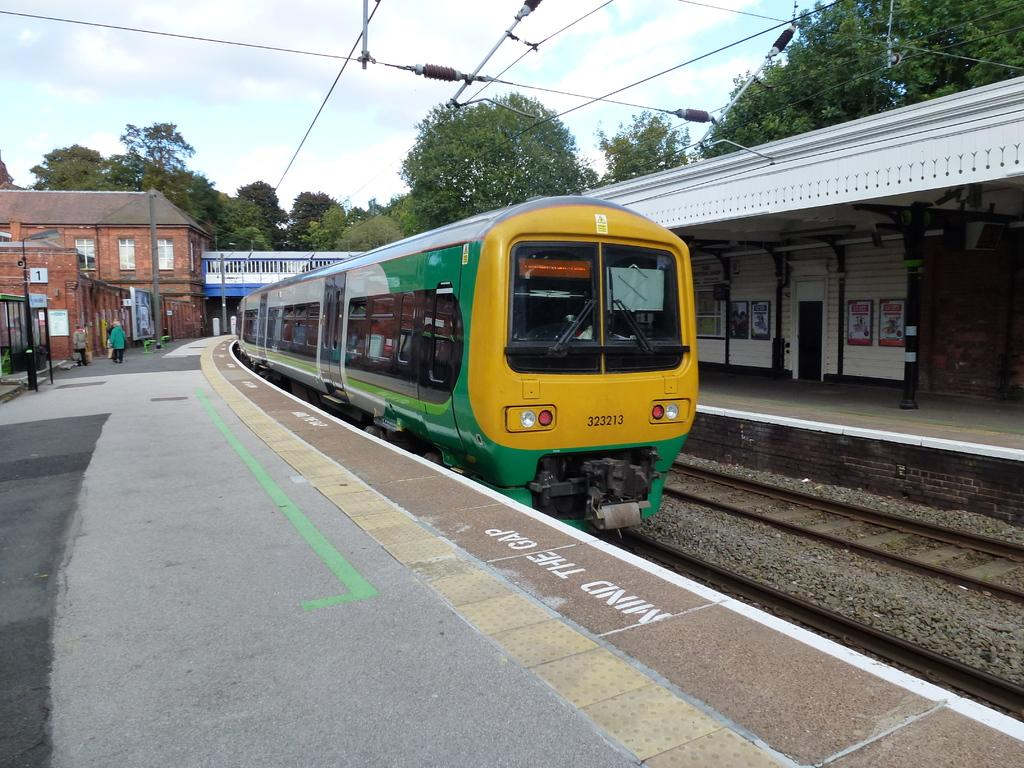<image>
Offer a succinct explanation of the picture presented. Stenciled words on a train platform remind passengers to mind the gap. 